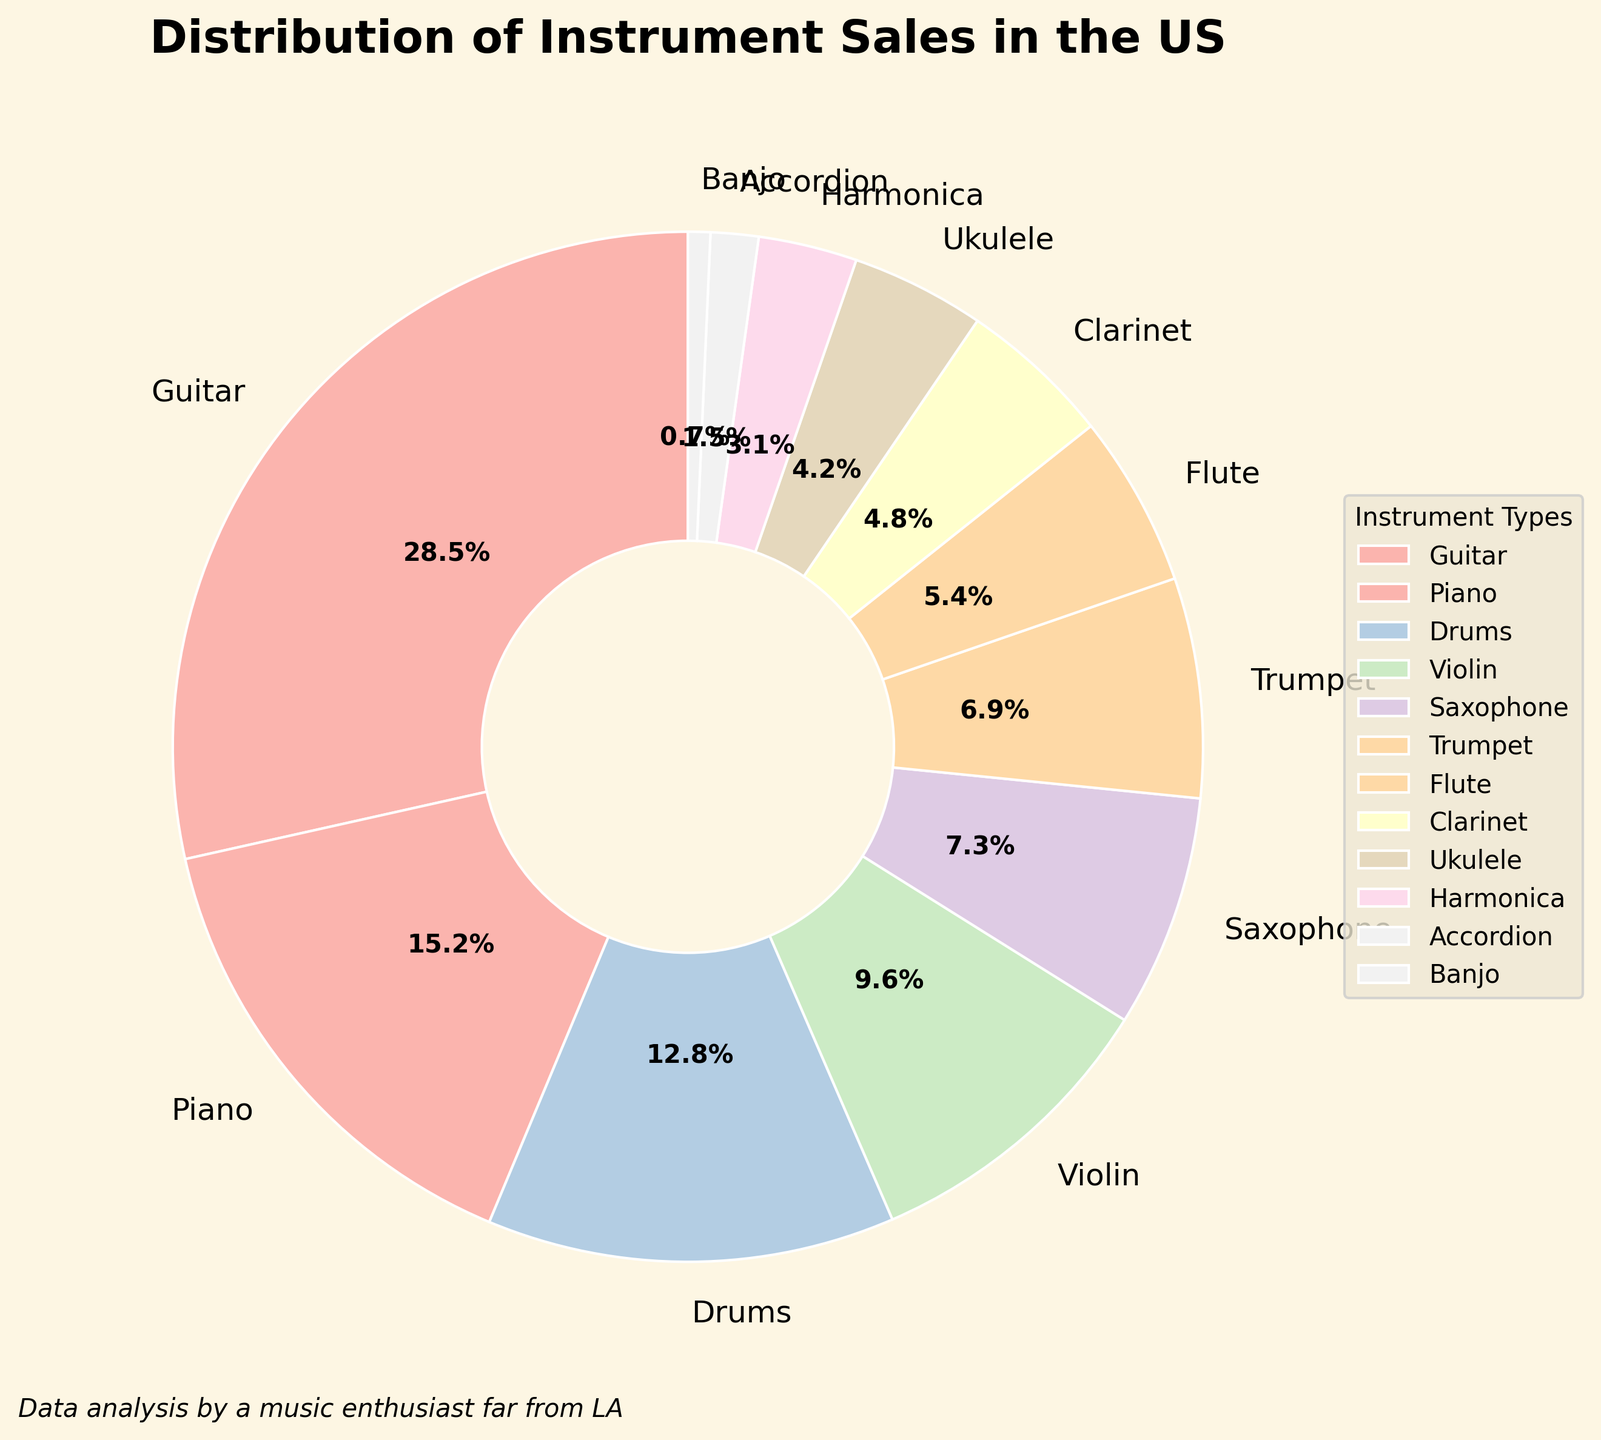What's the total sales percentage of Guitar, Piano, and Drums? The sales percentages for Guitar, Piano, and Drums are 28.5%, 15.2%, and 12.8% respectively. Summing them up: 28.5 + 15.2 + 12.8 = 56.5
Answer: 56.5% Which instrument has the highest sales percentage? By observing the pie chart, the wedge with the largest area corresponds to Guitar with a sales percentage of 28.5%.
Answer: Guitar What is the difference in sales percentage between Violin and Saxophone? The sales percentage for Violin is 9.6% and for Saxophone is 7.3%. The difference is 9.6 - 7.3 = 2.3
Answer: 2.3% Are the combined sales percentages of Flute and Clarinet greater than that of Piano? The sales percentages of Flute and Clarinet are 5.4% and 4.8% respectively. Together they equal 5.4 + 4.8 = 10.2%. The sales percentage for Piano is 15.2%. 10.2% is less than 15.2%.
Answer: No Which instruments have sales percentages less than 5%? Observing the smaller wedges, the instruments with sales percentages less than 5% are Clarinet (4.8%), Ukulele (4.2%), Harmonica (3.1%), Accordion (1.5%), and Banjo (0.7%).
Answer: Clarinet, Ukulele, Harmonica, Accordion, Banjo How much greater is the sales percentage of Guitar compared to Harmonica? The sales percentage for Guitar is 28.5% and for Harmonica is 3.1%. The difference is 28.5 - 3.1 = 25.4
Answer: 25.4% Is the combined sales percentage of Trumpet and Flute greater than the sales percentage for Drums? The sales percentages for Trumpet and Flute are 6.9% and 5.4% respectively. Combined, they are 6.9 + 5.4 = 12.3%. The sales percentage for Drums is 12.8%. 12.3% is less than 12.8%.
Answer: No What fraction of the total sales does the Accordion represent? The Accordion sales percentage is 1.5%. In fraction form, this is 1.5/100 = 0.015
Answer: 0.015 What is the average sales percentage for Guitar, Piano, Violin, and Saxophone? The sales percentages are: Guitar 28.5%, Piano 15.2%, Violin 9.6%, and Saxophone 7.3%. Sum them: 28.5 + 15.2 + 9.6 + 7.3 = 60.6. Average them: 60.6 / 4 = 15.15
Answer: 15.15% Which instrument has a sales percentage closest to 10%? Observing the pie chart, the instrument closest to 10% is Violin with 9.6%.
Answer: Violin 